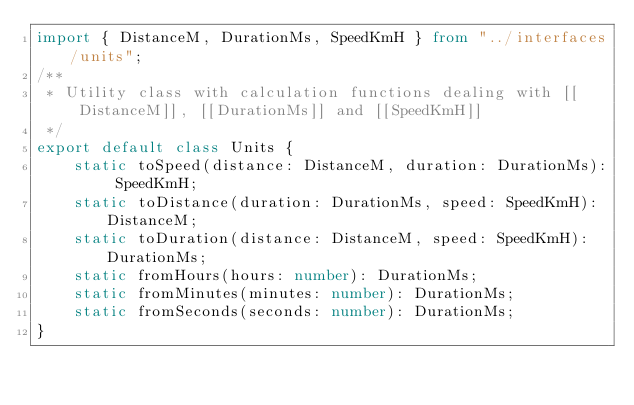<code> <loc_0><loc_0><loc_500><loc_500><_TypeScript_>import { DistanceM, DurationMs, SpeedKmH } from "../interfaces/units";
/**
 * Utility class with calculation functions dealing with [[DistanceM]], [[DurationMs]] and [[SpeedKmH]]
 */
export default class Units {
    static toSpeed(distance: DistanceM, duration: DurationMs): SpeedKmH;
    static toDistance(duration: DurationMs, speed: SpeedKmH): DistanceM;
    static toDuration(distance: DistanceM, speed: SpeedKmH): DurationMs;
    static fromHours(hours: number): DurationMs;
    static fromMinutes(minutes: number): DurationMs;
    static fromSeconds(seconds: number): DurationMs;
}
</code> 